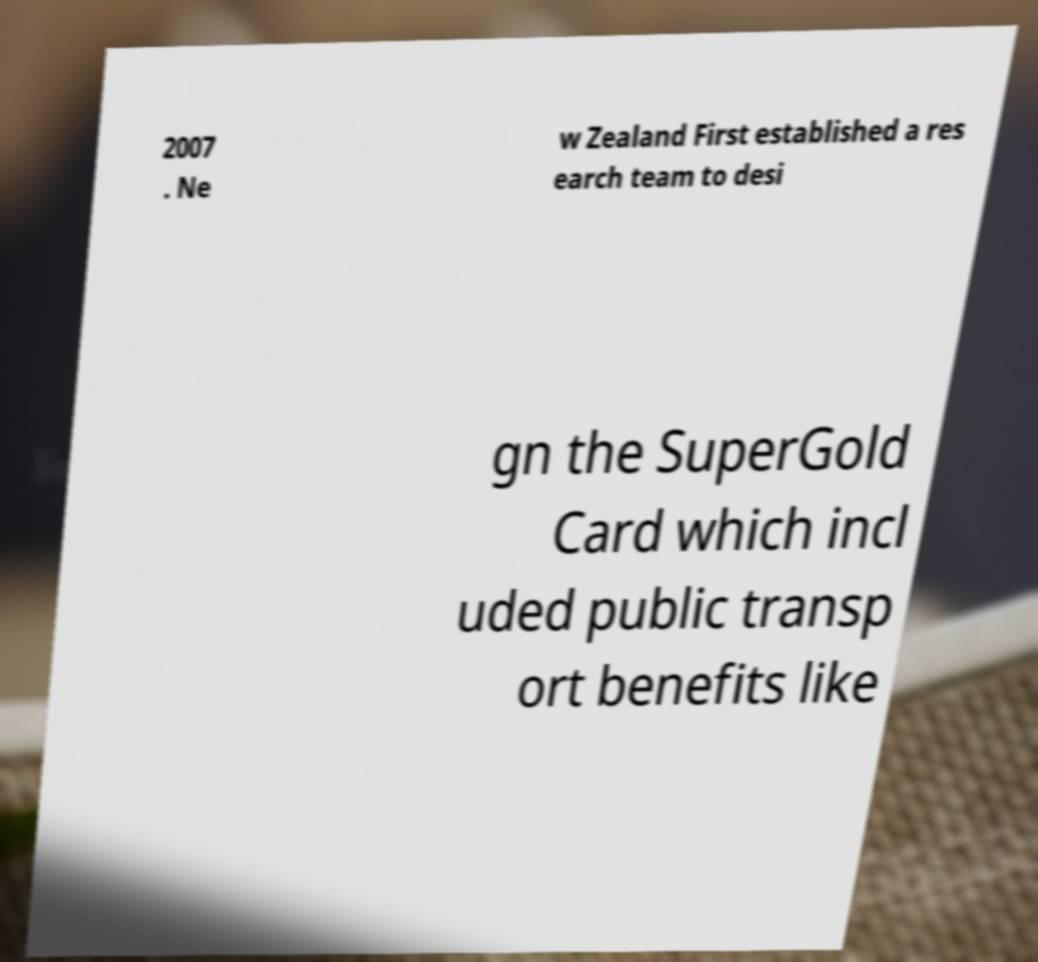Can you accurately transcribe the text from the provided image for me? 2007 . Ne w Zealand First established a res earch team to desi gn the SuperGold Card which incl uded public transp ort benefits like 